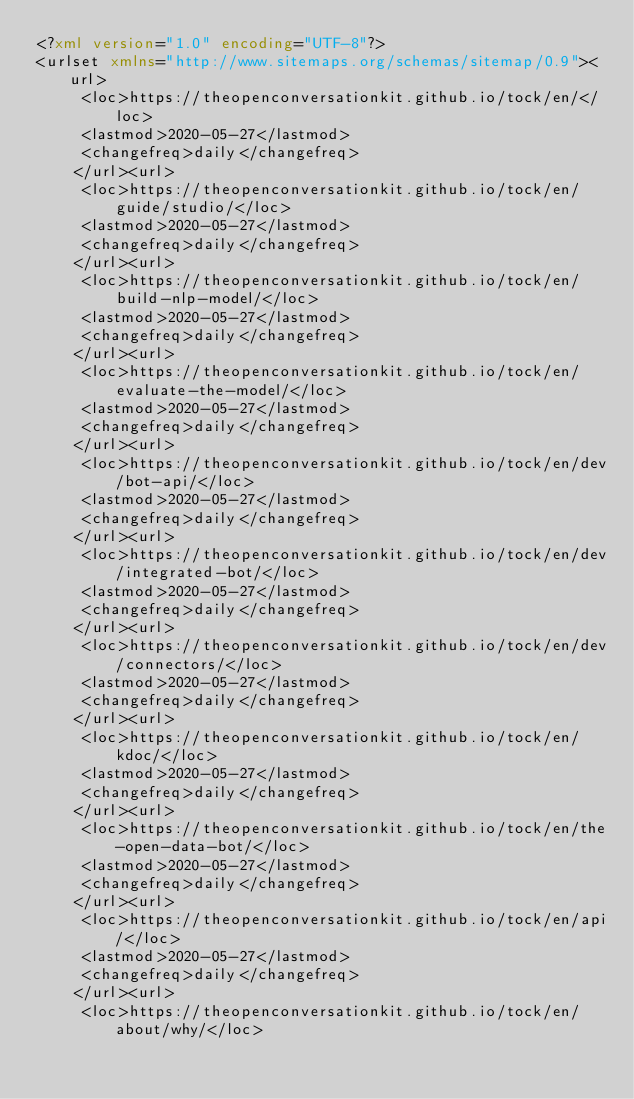<code> <loc_0><loc_0><loc_500><loc_500><_XML_><?xml version="1.0" encoding="UTF-8"?>
<urlset xmlns="http://www.sitemaps.org/schemas/sitemap/0.9"><url>
     <loc>https://theopenconversationkit.github.io/tock/en/</loc>
     <lastmod>2020-05-27</lastmod>
     <changefreq>daily</changefreq>
    </url><url>
     <loc>https://theopenconversationkit.github.io/tock/en/guide/studio/</loc>
     <lastmod>2020-05-27</lastmod>
     <changefreq>daily</changefreq>
    </url><url>
     <loc>https://theopenconversationkit.github.io/tock/en/build-nlp-model/</loc>
     <lastmod>2020-05-27</lastmod>
     <changefreq>daily</changefreq>
    </url><url>
     <loc>https://theopenconversationkit.github.io/tock/en/evaluate-the-model/</loc>
     <lastmod>2020-05-27</lastmod>
     <changefreq>daily</changefreq>
    </url><url>
     <loc>https://theopenconversationkit.github.io/tock/en/dev/bot-api/</loc>
     <lastmod>2020-05-27</lastmod>
     <changefreq>daily</changefreq>
    </url><url>
     <loc>https://theopenconversationkit.github.io/tock/en/dev/integrated-bot/</loc>
     <lastmod>2020-05-27</lastmod>
     <changefreq>daily</changefreq>
    </url><url>
     <loc>https://theopenconversationkit.github.io/tock/en/dev/connectors/</loc>
     <lastmod>2020-05-27</lastmod>
     <changefreq>daily</changefreq>
    </url><url>
     <loc>https://theopenconversationkit.github.io/tock/en/kdoc/</loc>
     <lastmod>2020-05-27</lastmod>
     <changefreq>daily</changefreq>
    </url><url>
     <loc>https://theopenconversationkit.github.io/tock/en/the-open-data-bot/</loc>
     <lastmod>2020-05-27</lastmod>
     <changefreq>daily</changefreq>
    </url><url>
     <loc>https://theopenconversationkit.github.io/tock/en/api/</loc>
     <lastmod>2020-05-27</lastmod>
     <changefreq>daily</changefreq>
    </url><url>
     <loc>https://theopenconversationkit.github.io/tock/en/about/why/</loc></code> 